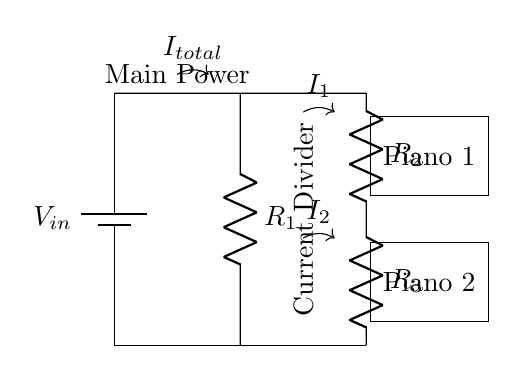What is the total current entering the circuit? The total current entering the circuit is denoted as I total. It is the sum of all currents flowing into the circuit from the power source.
Answer: I total What are the resistances in this circuit? The resistances in this circuit are R1, R2, and R3. These resistors are identified by their labels on the circuit and are an essential part of the current divider principle.
Answer: R1, R2, R3 Which piano module receives more current? The piano module connected to resistor R2 receives more current. Given that R2 is in the current divider and assuming R2 has a lower resistance compared to R3, by Ohm’s law, the branch with the lower resistance will draw more current.
Answer: Piano 1 What is the purpose of the current divider in this circuit? The purpose of the current divider is to distribute the total input current among the branches connected to the piano modules. This allows for proportional power distribution based on the resistances in each branch.
Answer: Distribute power What is the relationship between the resistances and the currents in the branches? The currents in the branches are inversely proportional to the resistances of R2 and R3. Higher resistance means less current flows through that branch, while a lower resistance allows more current to flow through it. This is a key principle of the current divider.
Answer: Inverse proportionality How is the current I1 defined in relation to I total? The current I1 is defined as a portion of the total current I total that flows through resistor R2. According to the current divider rule, I1 can be calculated based on the voltage across R2 and its resistance.
Answer: A portion of I total 